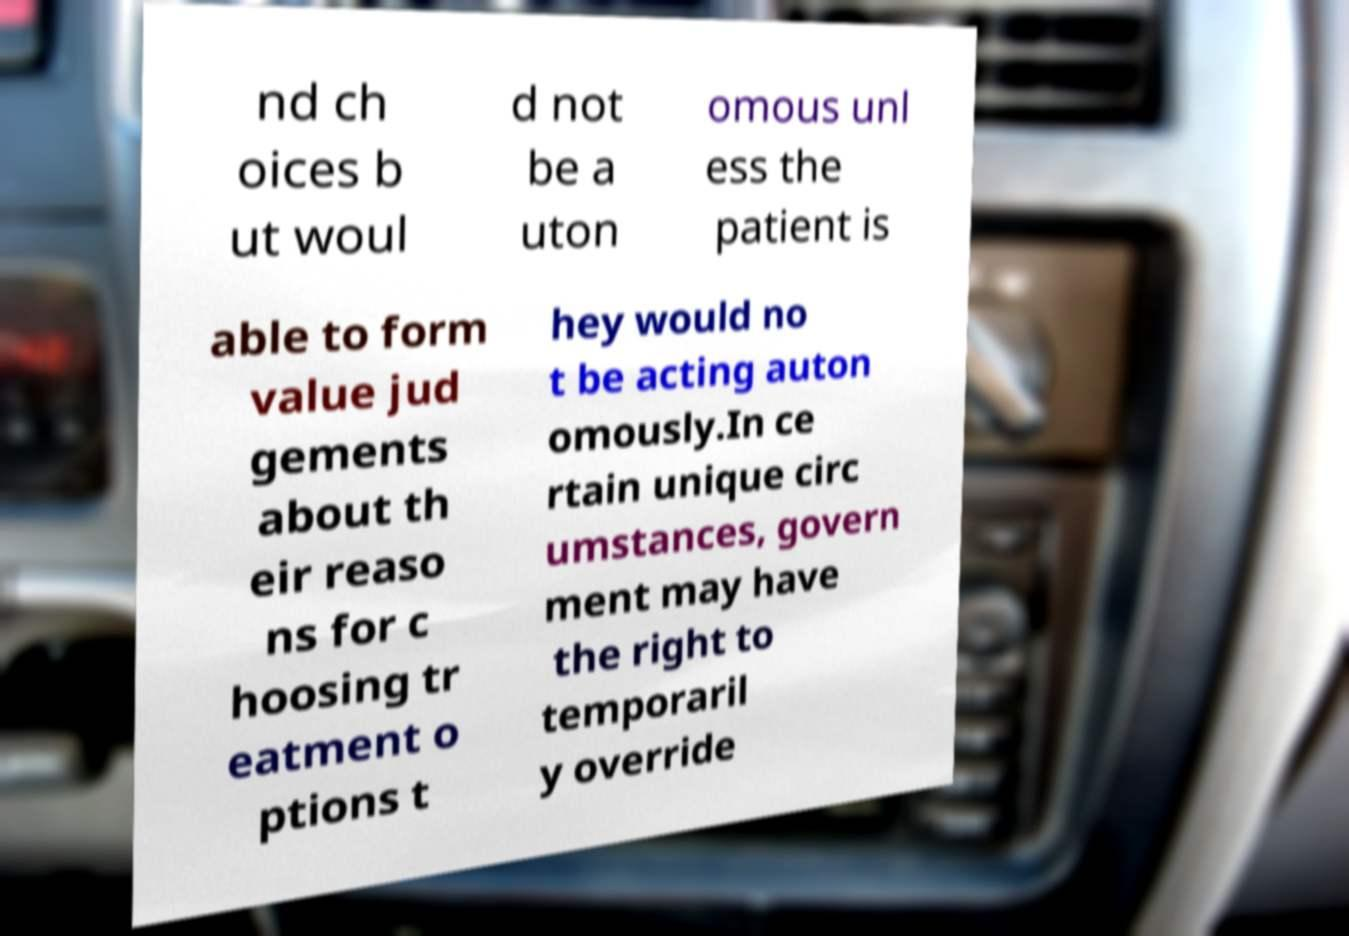Can you accurately transcribe the text from the provided image for me? nd ch oices b ut woul d not be a uton omous unl ess the patient is able to form value jud gements about th eir reaso ns for c hoosing tr eatment o ptions t hey would no t be acting auton omously.In ce rtain unique circ umstances, govern ment may have the right to temporaril y override 